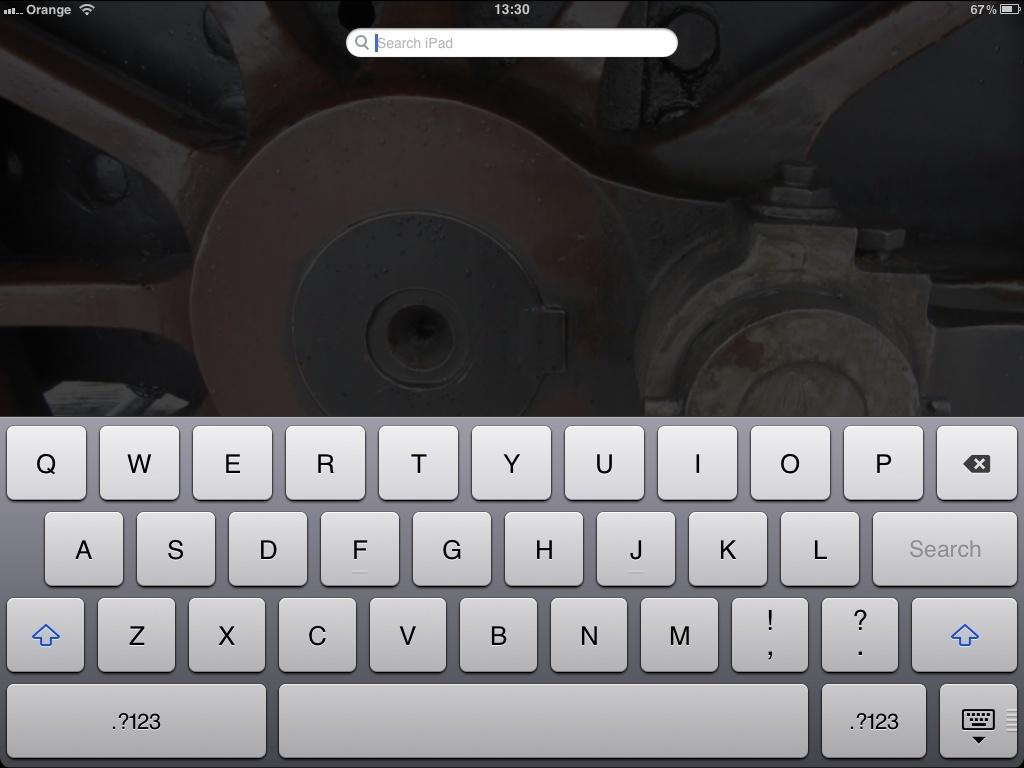What is the main subject of the image? The main subject of the image is a screen. What can be seen on the screen? There is a keyboard and a search bar visible on the screen. What type of vein is visible on the screen in the image? There is no vein visible on the screen in the image; it is a screen displaying a keyboard and a search bar. 